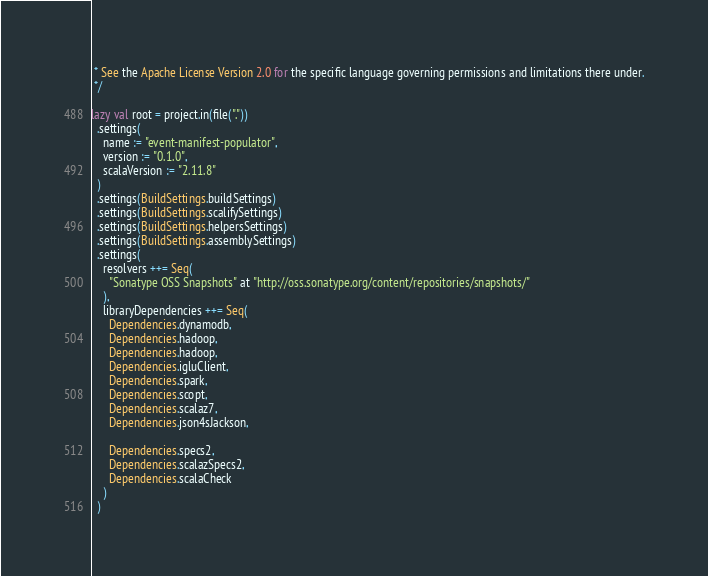Convert code to text. <code><loc_0><loc_0><loc_500><loc_500><_Scala_> * See the Apache License Version 2.0 for the specific language governing permissions and limitations there under.
 */

lazy val root = project.in(file("."))
  .settings(
    name := "event-manifest-populator",
    version := "0.1.0",
    scalaVersion := "2.11.8"
  )
  .settings(BuildSettings.buildSettings)
  .settings(BuildSettings.scalifySettings)
  .settings(BuildSettings.helpersSettings)
  .settings(BuildSettings.assemblySettings)
  .settings(
    resolvers ++= Seq(
      "Sonatype OSS Snapshots" at "http://oss.sonatype.org/content/repositories/snapshots/"
    ),
    libraryDependencies ++= Seq(
      Dependencies.dynamodb,
      Dependencies.hadoop,
      Dependencies.hadoop,
      Dependencies.igluClient,
      Dependencies.spark,
      Dependencies.scopt,
      Dependencies.scalaz7,
      Dependencies.json4sJackson,

      Dependencies.specs2,
      Dependencies.scalazSpecs2,
      Dependencies.scalaCheck
    )
  )



</code> 